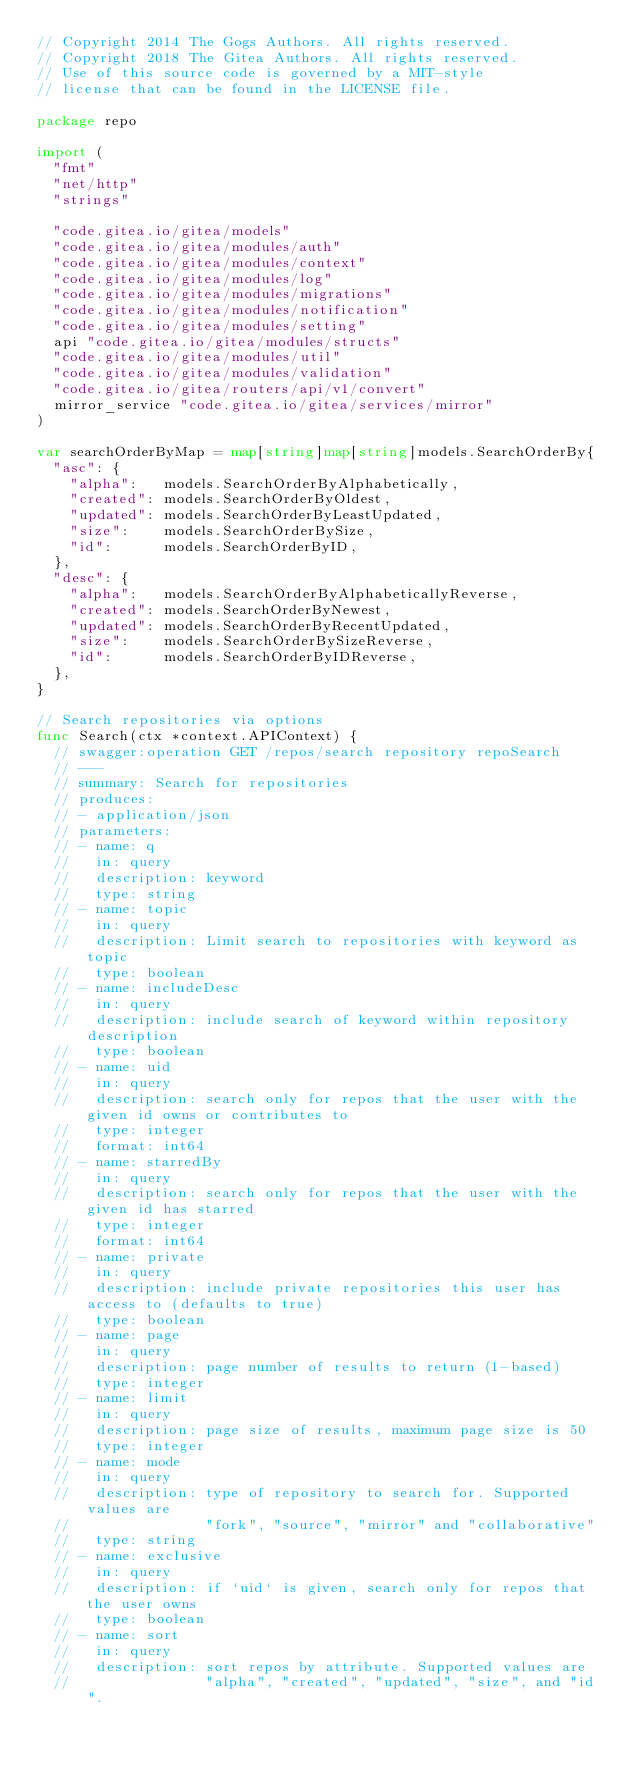<code> <loc_0><loc_0><loc_500><loc_500><_Go_>// Copyright 2014 The Gogs Authors. All rights reserved.
// Copyright 2018 The Gitea Authors. All rights reserved.
// Use of this source code is governed by a MIT-style
// license that can be found in the LICENSE file.

package repo

import (
	"fmt"
	"net/http"
	"strings"

	"code.gitea.io/gitea/models"
	"code.gitea.io/gitea/modules/auth"
	"code.gitea.io/gitea/modules/context"
	"code.gitea.io/gitea/modules/log"
	"code.gitea.io/gitea/modules/migrations"
	"code.gitea.io/gitea/modules/notification"
	"code.gitea.io/gitea/modules/setting"
	api "code.gitea.io/gitea/modules/structs"
	"code.gitea.io/gitea/modules/util"
	"code.gitea.io/gitea/modules/validation"
	"code.gitea.io/gitea/routers/api/v1/convert"
	mirror_service "code.gitea.io/gitea/services/mirror"
)

var searchOrderByMap = map[string]map[string]models.SearchOrderBy{
	"asc": {
		"alpha":   models.SearchOrderByAlphabetically,
		"created": models.SearchOrderByOldest,
		"updated": models.SearchOrderByLeastUpdated,
		"size":    models.SearchOrderBySize,
		"id":      models.SearchOrderByID,
	},
	"desc": {
		"alpha":   models.SearchOrderByAlphabeticallyReverse,
		"created": models.SearchOrderByNewest,
		"updated": models.SearchOrderByRecentUpdated,
		"size":    models.SearchOrderBySizeReverse,
		"id":      models.SearchOrderByIDReverse,
	},
}

// Search repositories via options
func Search(ctx *context.APIContext) {
	// swagger:operation GET /repos/search repository repoSearch
	// ---
	// summary: Search for repositories
	// produces:
	// - application/json
	// parameters:
	// - name: q
	//   in: query
	//   description: keyword
	//   type: string
	// - name: topic
	//   in: query
	//   description: Limit search to repositories with keyword as topic
	//   type: boolean
	// - name: includeDesc
	//   in: query
	//   description: include search of keyword within repository description
	//   type: boolean
	// - name: uid
	//   in: query
	//   description: search only for repos that the user with the given id owns or contributes to
	//   type: integer
	//   format: int64
	// - name: starredBy
	//   in: query
	//   description: search only for repos that the user with the given id has starred
	//   type: integer
	//   format: int64
	// - name: private
	//   in: query
	//   description: include private repositories this user has access to (defaults to true)
	//   type: boolean
	// - name: page
	//   in: query
	//   description: page number of results to return (1-based)
	//   type: integer
	// - name: limit
	//   in: query
	//   description: page size of results, maximum page size is 50
	//   type: integer
	// - name: mode
	//   in: query
	//   description: type of repository to search for. Supported values are
	//                "fork", "source", "mirror" and "collaborative"
	//   type: string
	// - name: exclusive
	//   in: query
	//   description: if `uid` is given, search only for repos that the user owns
	//   type: boolean
	// - name: sort
	//   in: query
	//   description: sort repos by attribute. Supported values are
	//                "alpha", "created", "updated", "size", and "id".</code> 